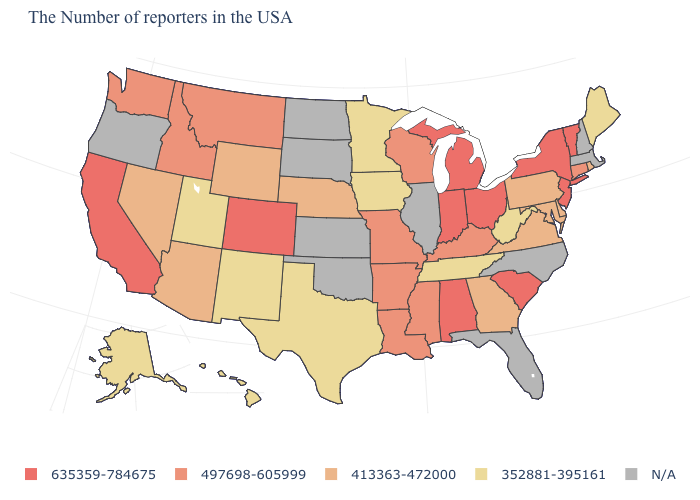What is the highest value in states that border Iowa?
Keep it brief. 497698-605999. Which states hav the highest value in the MidWest?
Answer briefly. Ohio, Michigan, Indiana. Among the states that border New York , does Vermont have the highest value?
Quick response, please. Yes. What is the value of Oklahoma?
Keep it brief. N/A. Name the states that have a value in the range 497698-605999?
Write a very short answer. Connecticut, Kentucky, Wisconsin, Mississippi, Louisiana, Missouri, Arkansas, Montana, Idaho, Washington. What is the value of Maryland?
Quick response, please. 413363-472000. What is the value of Colorado?
Keep it brief. 635359-784675. Among the states that border Massachusetts , which have the lowest value?
Answer briefly. Rhode Island. What is the highest value in the USA?
Short answer required. 635359-784675. What is the value of Missouri?
Keep it brief. 497698-605999. Does the first symbol in the legend represent the smallest category?
Be succinct. No. Name the states that have a value in the range N/A?
Be succinct. Massachusetts, New Hampshire, North Carolina, Florida, Illinois, Kansas, Oklahoma, South Dakota, North Dakota, Oregon. Is the legend a continuous bar?
Concise answer only. No. Is the legend a continuous bar?
Give a very brief answer. No. 